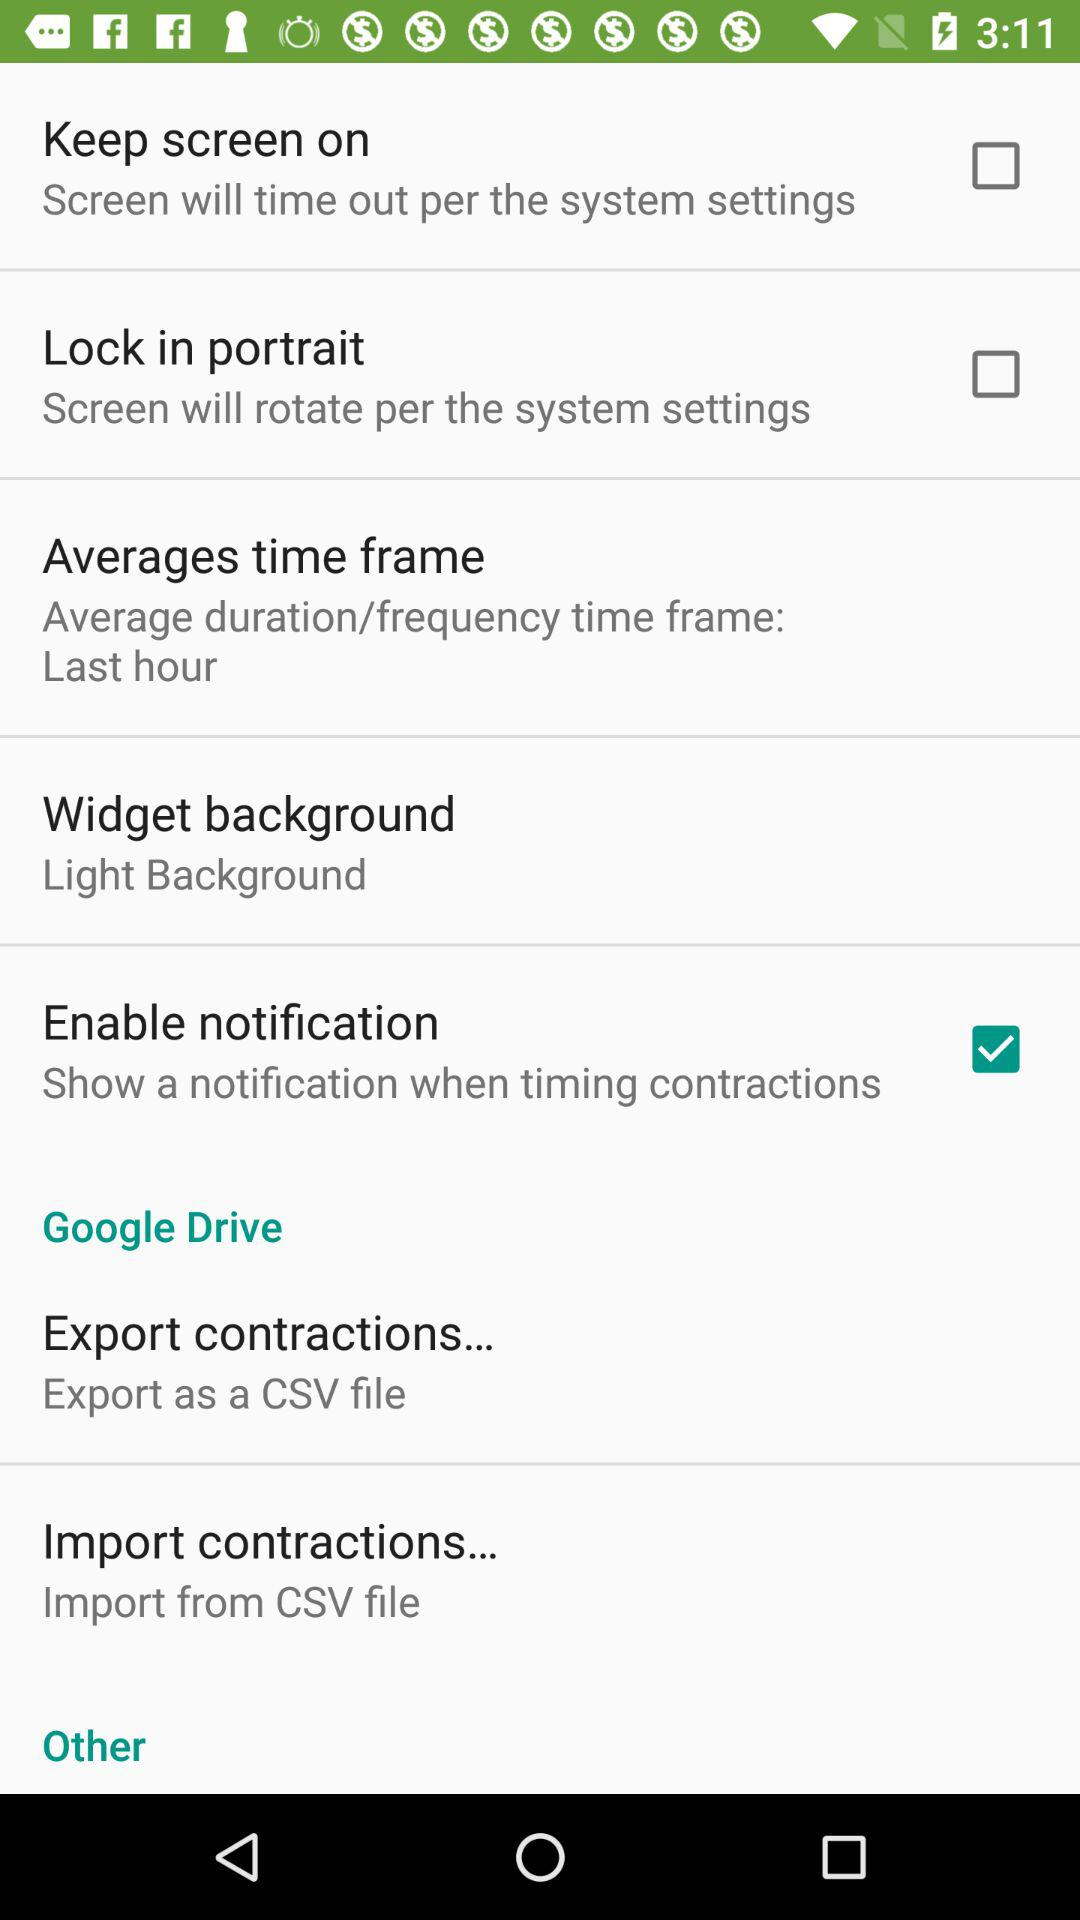Is the setting "Keep screen on" enabled or disabled?
Answer the question using a single word or phrase. It is "disabled". 